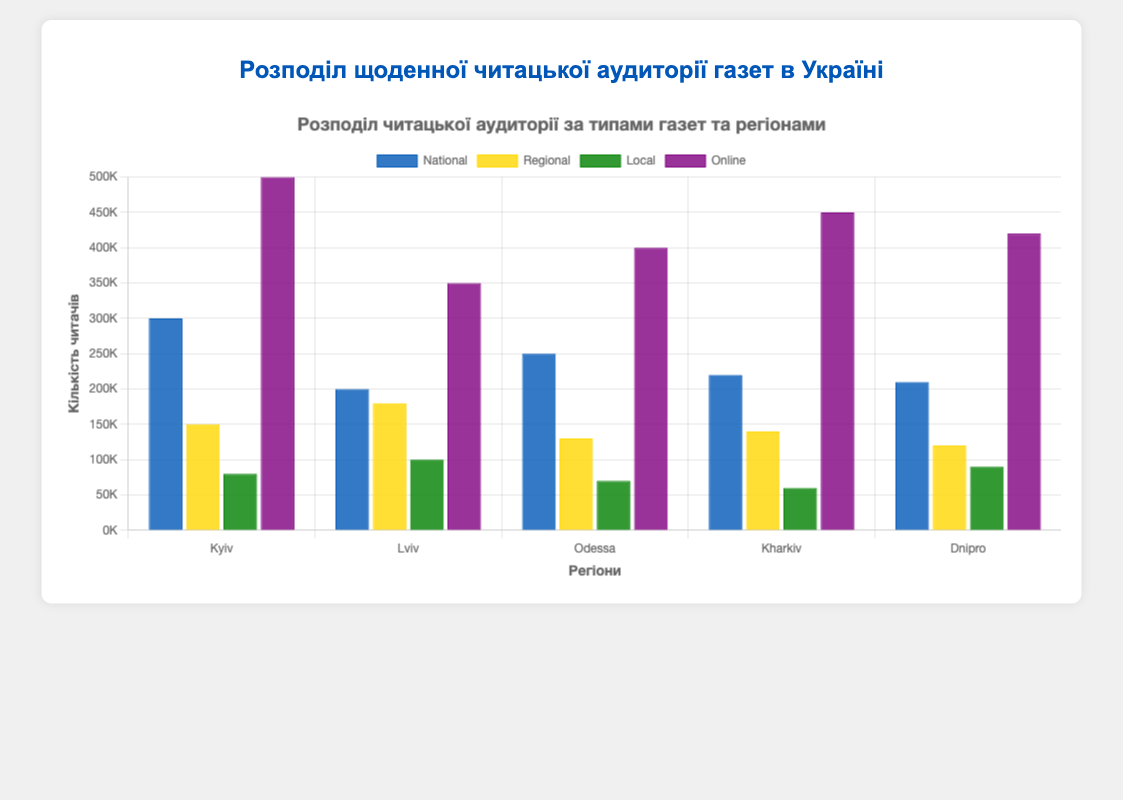Which region has the highest online newspaper readership? To determine the region with the highest online newspaper readership, compare the bar heights for the 'Online' category across all regions. The tallest bar represents the region with the highest readership.
Answer: Kyiv What is the total readership of local newspapers in Kyiv and Dnipro? Add the local newspaper readership numbers for Kyiv (80,000) and Dnipro (90,000).
Answer: 170,000 Which type of newspaper in Kharkiv has the least readership? Look at the different bars representing each newspaper type within Kharkiv and identify the shortest one. The shortest bar corresponds to the type with the least readership.
Answer: Local Compare the national newspaper readership between Lviv and Odessa. Which one is higher and by how much? Subtract the national newspaper readership in Lviv (200,000) from that in Odessa (250,000). The result indicates that Odessa has a higher readership by 50,000.
Answer: Odessa, 50,000 What is the average regional newspaper readership across all regions? Sum up the regional newspaper readership numbers for all regions (150,000 + 180,000 + 130,000 + 140,000 + 120,000) and divide by the number of regions (5). Calculation: (720,000 / 5)
Answer: 144,000 Which region has the second highest total newspaper readership (all types combined)? Calculate the total readership for each region by summing up the values for each newspaper type within the region. Compare these totals to identify the region with the second highest readership.
1. Kyiv: 1,030,000
2. Lviv: 830,000
3. Odessa: 850,000
4. Kharkiv: 870,000
5. Dnipro: 840,000
Lviv has the second highest total readership.
Answer: Kharkiv Which newspaper type has the most consistent readership distribution across all regions? Calculate the range (difference between highest and lowest readership) for each newspaper type across all regions and compare these ranges. The type with the smallest range is the most consistent.
1. National: 300,000 - 200,000 = 100,000
2. Regional: 180,000 - 120,000 = 60,000
3. Local: 100,000 - 60,000 = 40,000
4. Online: 500,000 - 350,000 = 150,000
Local newspapers have the narrowest range of distribution, making them the most consistent.
Answer: Local Which regions have a higher online readership than national readership? Compare the 'Online' and 'National' readership bars in each region. The regions where the online bar is taller than the national bar are Kyiv, Lviv, Odessa, Kharkiv, and Dnipro.
Answer: Kyiv, Lviv, Odessa, Kharkiv, Dnipro Among all regions, which one has the lowest readership for regional newspapers? Compare the heights of the bars representing regional newspapers for all regions and find the shortest one.
Answer: Dnipro How does the local newspaper readership in Odessa compare to Dnipro? Subtract the local newspaper readership in Odessa (70,000) from that in Dnipro (90,000). The result shows Dnipro has 20,000 more readers for local newspapers.
Answer: Dnipro, 20,000 